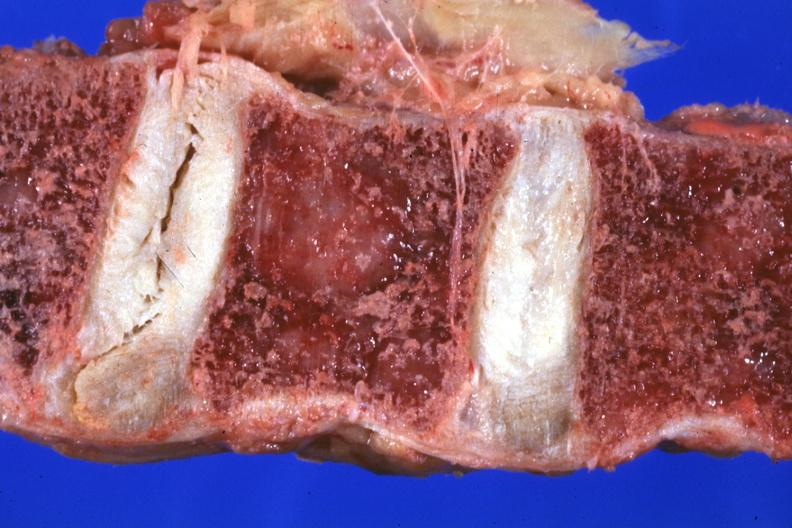does this image show close-up vertebral body excellent?
Answer the question using a single word or phrase. Yes 